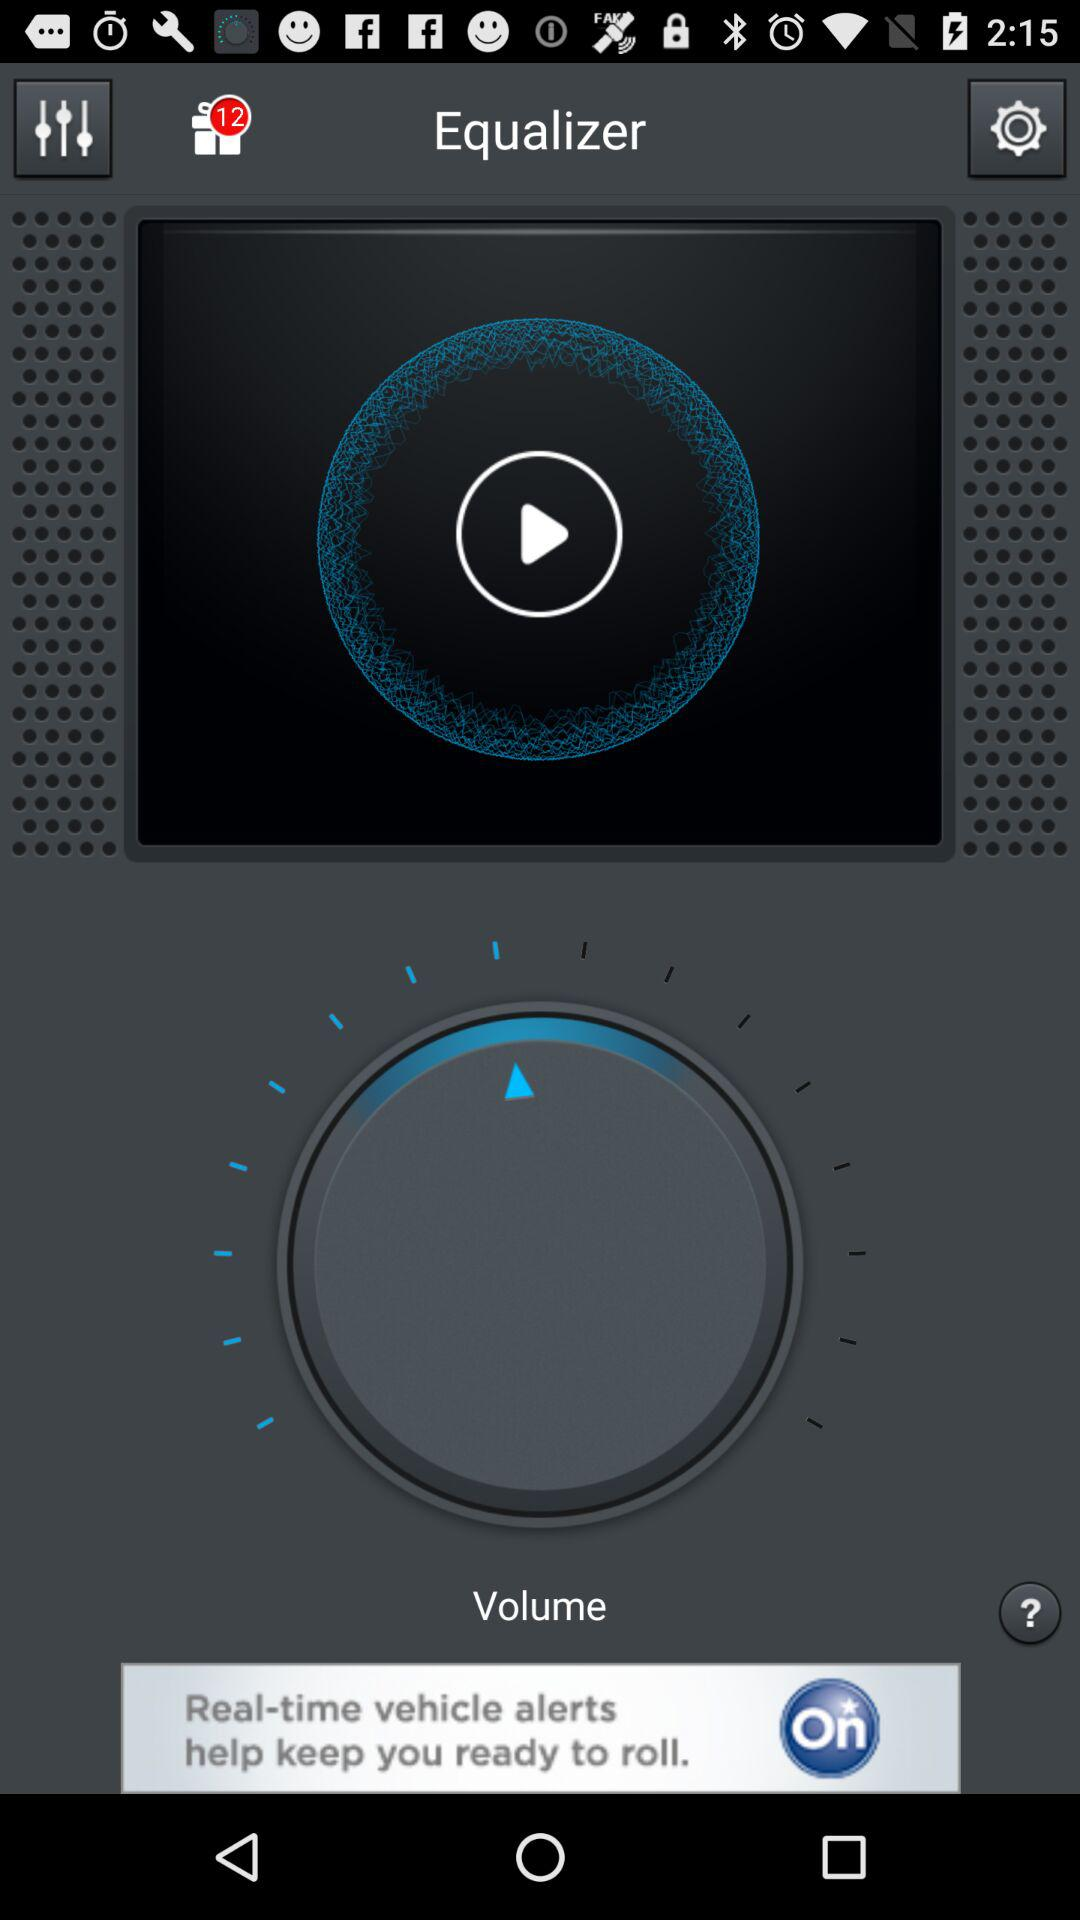What is the name of the application? The name of the application is "Equalizer". 